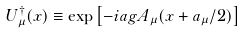<formula> <loc_0><loc_0><loc_500><loc_500>U _ { \mu } ^ { \dagger } ( x ) \equiv \exp \left [ - i a g A _ { \mu } ( x + a _ { \mu } / 2 ) \right ]</formula> 